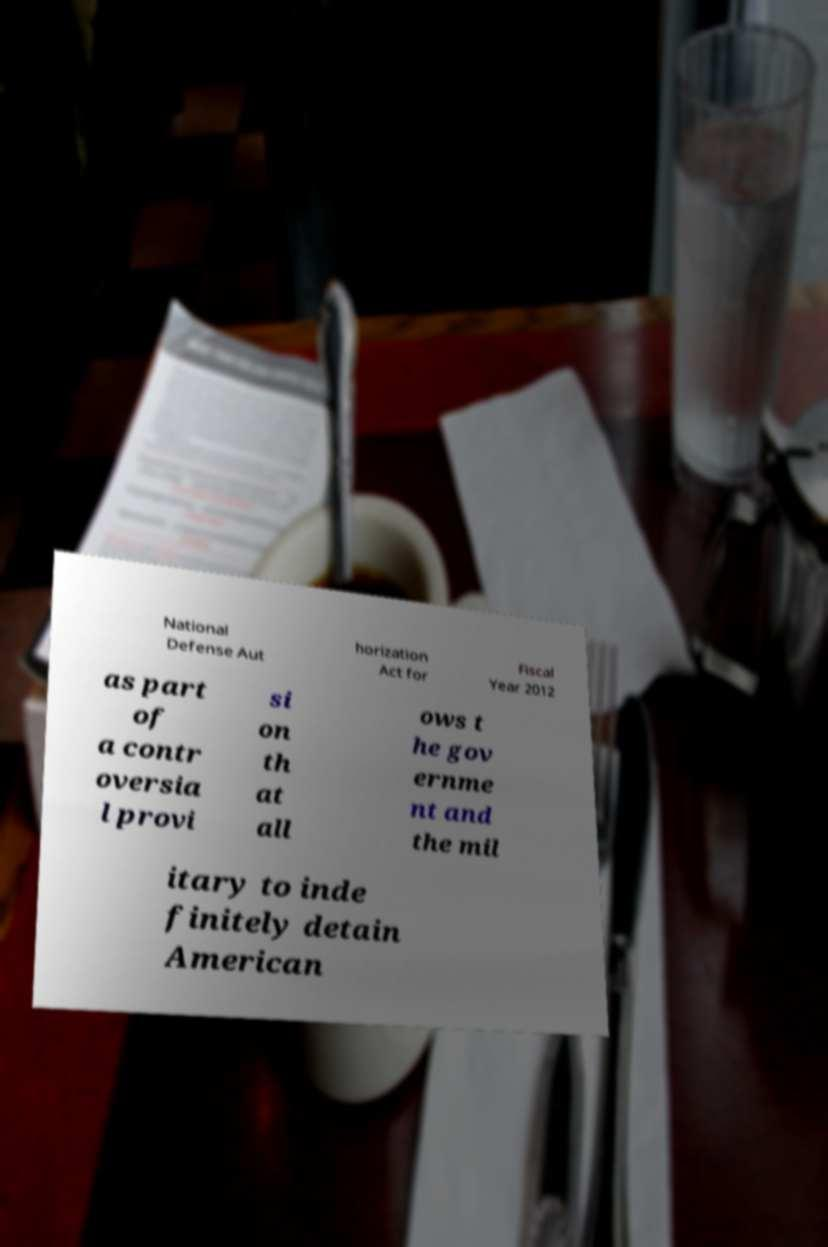Can you read and provide the text displayed in the image?This photo seems to have some interesting text. Can you extract and type it out for me? National Defense Aut horization Act for Fiscal Year 2012 as part of a contr oversia l provi si on th at all ows t he gov ernme nt and the mil itary to inde finitely detain American 